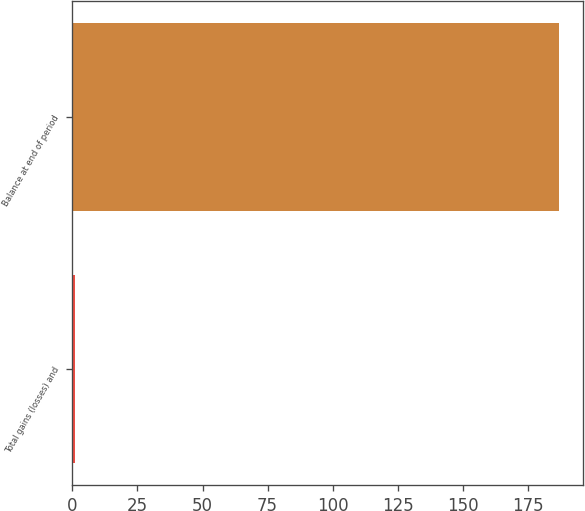<chart> <loc_0><loc_0><loc_500><loc_500><bar_chart><fcel>Total gains (losses) and<fcel>Balance at end of period<nl><fcel>1<fcel>187<nl></chart> 